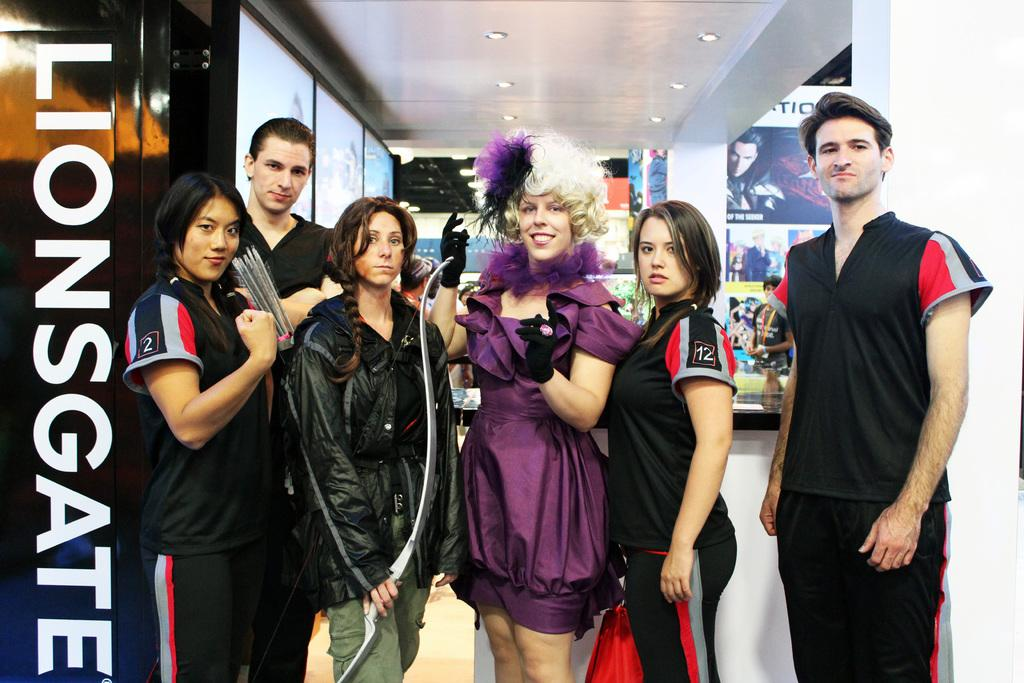Provide a one-sentence caption for the provided image. A Lionsgate photo shows six people dressed in odd clothing. 